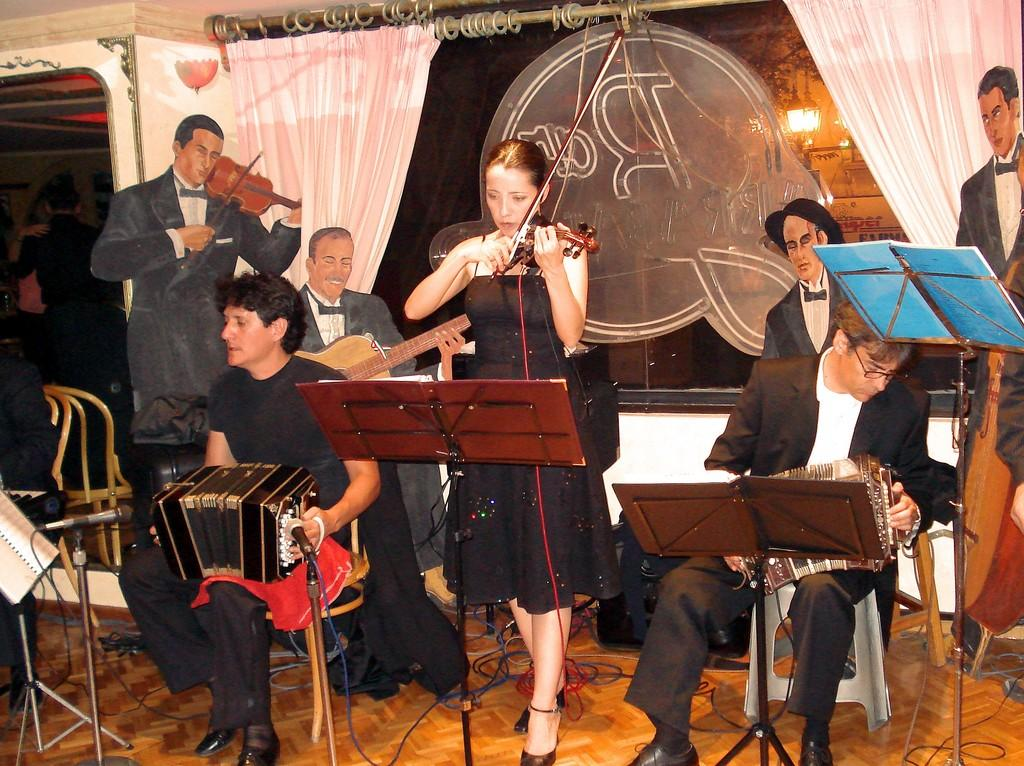What are the people in the image doing? The people in the image are playing musical instruments. Can you describe the background of the image? There is a poster in the background of the image. How many eggs are visible on the poster in the image? There are no eggs visible on the poster in the image, as the poster is not described in detail. 